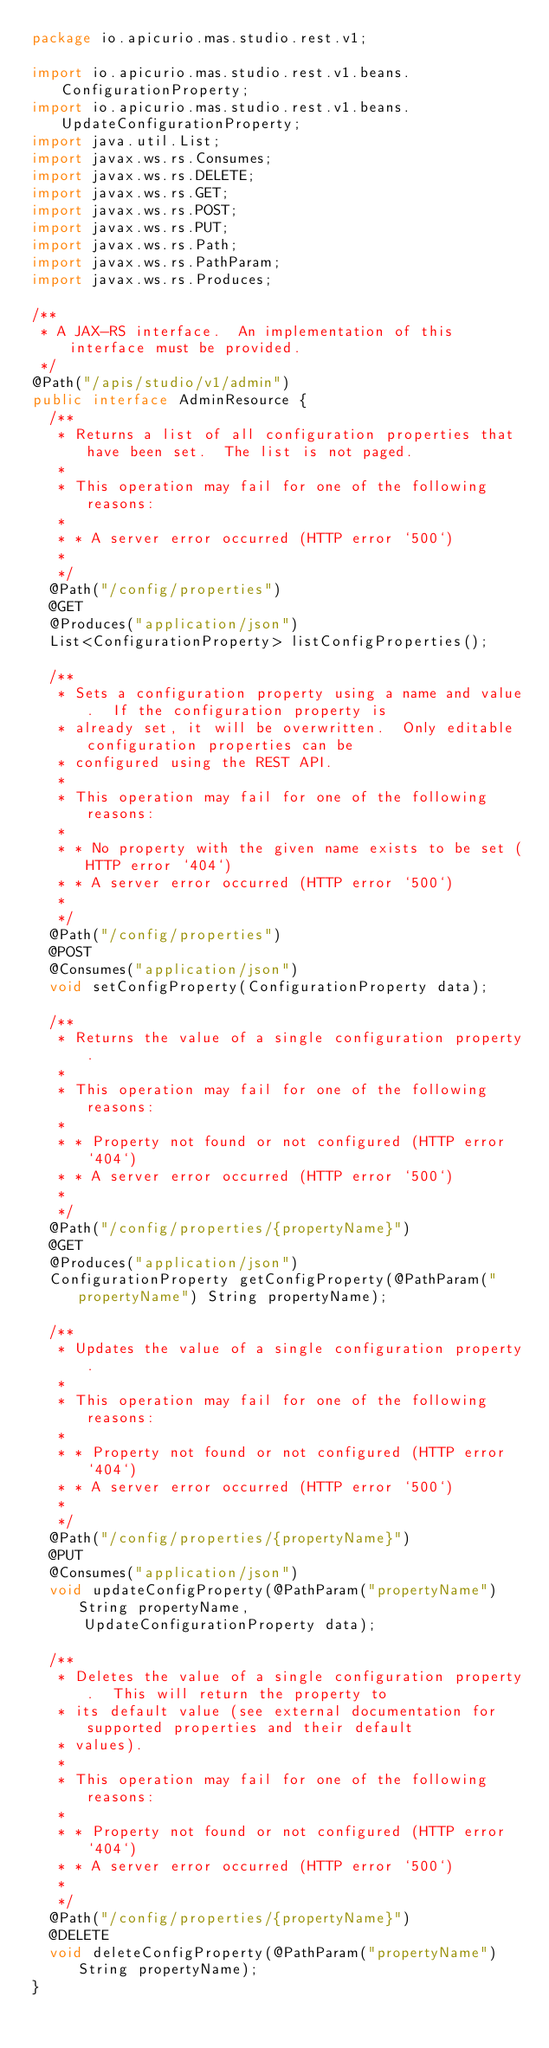<code> <loc_0><loc_0><loc_500><loc_500><_Java_>package io.apicurio.mas.studio.rest.v1;

import io.apicurio.mas.studio.rest.v1.beans.ConfigurationProperty;
import io.apicurio.mas.studio.rest.v1.beans.UpdateConfigurationProperty;
import java.util.List;
import javax.ws.rs.Consumes;
import javax.ws.rs.DELETE;
import javax.ws.rs.GET;
import javax.ws.rs.POST;
import javax.ws.rs.PUT;
import javax.ws.rs.Path;
import javax.ws.rs.PathParam;
import javax.ws.rs.Produces;

/**
 * A JAX-RS interface.  An implementation of this interface must be provided.
 */
@Path("/apis/studio/v1/admin")
public interface AdminResource {
  /**
   * Returns a list of all configuration properties that have been set.  The list is not paged.
   *
   * This operation may fail for one of the following reasons:
   *
   * * A server error occurred (HTTP error `500`)
   *
   */
  @Path("/config/properties")
  @GET
  @Produces("application/json")
  List<ConfigurationProperty> listConfigProperties();

  /**
   * Sets a configuration property using a name and value.  If the configuration property is
   * already set, it will be overwritten.  Only editable configuration properties can be 
   * configured using the REST API.
   *
   * This operation may fail for one of the following reasons:
   *
   * * No property with the given name exists to be set (HTTP error `404`)
   * * A server error occurred (HTTP error `500`)
   *
   */
  @Path("/config/properties")
  @POST
  @Consumes("application/json")
  void setConfigProperty(ConfigurationProperty data);

  /**
   * Returns the value of a single configuration property.
   *
   * This operation may fail for one of the following reasons:
   *
   * * Property not found or not configured (HTTP error `404`)
   * * A server error occurred (HTTP error `500`)
   *
   */
  @Path("/config/properties/{propertyName}")
  @GET
  @Produces("application/json")
  ConfigurationProperty getConfigProperty(@PathParam("propertyName") String propertyName);

  /**
   * Updates the value of a single configuration property.
   *
   * This operation may fail for one of the following reasons:
   *
   * * Property not found or not configured (HTTP error `404`)
   * * A server error occurred (HTTP error `500`)
   *
   */
  @Path("/config/properties/{propertyName}")
  @PUT
  @Consumes("application/json")
  void updateConfigProperty(@PathParam("propertyName") String propertyName,
      UpdateConfigurationProperty data);

  /**
   * Deletes the value of a single configuration property.  This will return the property to
   * its default value (see external documentation for supported properties and their default
   * values).
   *
   * This operation may fail for one of the following reasons:
   *
   * * Property not found or not configured (HTTP error `404`)
   * * A server error occurred (HTTP error `500`)
   *
   */
  @Path("/config/properties/{propertyName}")
  @DELETE
  void deleteConfigProperty(@PathParam("propertyName") String propertyName);
}
</code> 